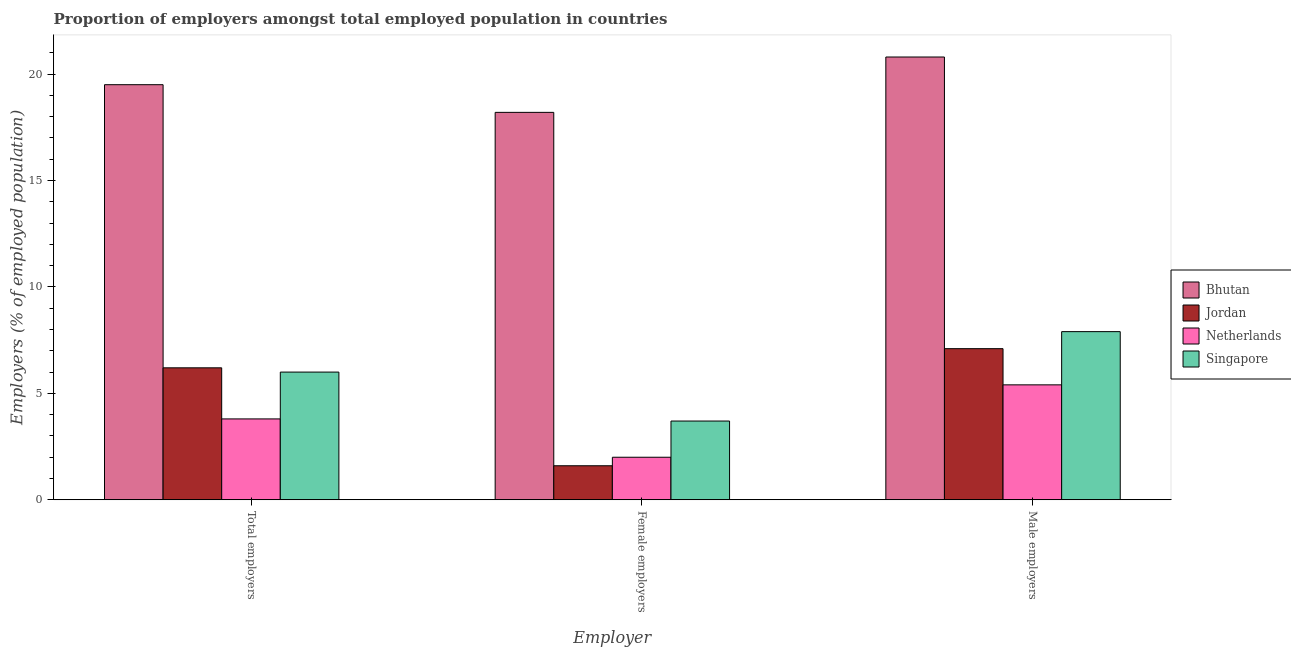How many different coloured bars are there?
Provide a short and direct response. 4. Are the number of bars on each tick of the X-axis equal?
Provide a short and direct response. Yes. How many bars are there on the 3rd tick from the left?
Your response must be concise. 4. What is the label of the 1st group of bars from the left?
Ensure brevity in your answer.  Total employers. What is the percentage of female employers in Netherlands?
Offer a terse response. 2. Across all countries, what is the maximum percentage of total employers?
Give a very brief answer. 19.5. Across all countries, what is the minimum percentage of total employers?
Your answer should be very brief. 3.8. In which country was the percentage of male employers maximum?
Your answer should be very brief. Bhutan. What is the total percentage of total employers in the graph?
Ensure brevity in your answer.  35.5. What is the difference between the percentage of female employers in Netherlands and that in Jordan?
Make the answer very short. 0.4. What is the difference between the percentage of total employers in Jordan and the percentage of male employers in Netherlands?
Offer a very short reply. 0.8. What is the average percentage of female employers per country?
Give a very brief answer. 6.38. What is the difference between the percentage of total employers and percentage of female employers in Bhutan?
Your answer should be compact. 1.3. In how many countries, is the percentage of female employers greater than 1 %?
Offer a very short reply. 4. What is the ratio of the percentage of female employers in Singapore to that in Jordan?
Your response must be concise. 2.31. Is the percentage of male employers in Bhutan less than that in Netherlands?
Provide a short and direct response. No. What is the difference between the highest and the second highest percentage of total employers?
Ensure brevity in your answer.  13.3. What is the difference between the highest and the lowest percentage of female employers?
Offer a very short reply. 16.6. What does the 4th bar from the left in Male employers represents?
Provide a short and direct response. Singapore. What does the 1st bar from the right in Female employers represents?
Offer a very short reply. Singapore. How many bars are there?
Your answer should be compact. 12. Are all the bars in the graph horizontal?
Make the answer very short. No. Does the graph contain any zero values?
Keep it short and to the point. No. How are the legend labels stacked?
Ensure brevity in your answer.  Vertical. What is the title of the graph?
Offer a terse response. Proportion of employers amongst total employed population in countries. Does "Timor-Leste" appear as one of the legend labels in the graph?
Your answer should be very brief. No. What is the label or title of the X-axis?
Your answer should be compact. Employer. What is the label or title of the Y-axis?
Your answer should be very brief. Employers (% of employed population). What is the Employers (% of employed population) of Bhutan in Total employers?
Your response must be concise. 19.5. What is the Employers (% of employed population) in Jordan in Total employers?
Your answer should be very brief. 6.2. What is the Employers (% of employed population) of Netherlands in Total employers?
Offer a terse response. 3.8. What is the Employers (% of employed population) of Singapore in Total employers?
Ensure brevity in your answer.  6. What is the Employers (% of employed population) in Bhutan in Female employers?
Offer a very short reply. 18.2. What is the Employers (% of employed population) of Jordan in Female employers?
Make the answer very short. 1.6. What is the Employers (% of employed population) of Netherlands in Female employers?
Keep it short and to the point. 2. What is the Employers (% of employed population) in Singapore in Female employers?
Offer a very short reply. 3.7. What is the Employers (% of employed population) of Bhutan in Male employers?
Your answer should be compact. 20.8. What is the Employers (% of employed population) of Jordan in Male employers?
Offer a terse response. 7.1. What is the Employers (% of employed population) in Netherlands in Male employers?
Ensure brevity in your answer.  5.4. What is the Employers (% of employed population) of Singapore in Male employers?
Provide a succinct answer. 7.9. Across all Employer, what is the maximum Employers (% of employed population) of Bhutan?
Your answer should be very brief. 20.8. Across all Employer, what is the maximum Employers (% of employed population) in Jordan?
Keep it short and to the point. 7.1. Across all Employer, what is the maximum Employers (% of employed population) in Netherlands?
Keep it short and to the point. 5.4. Across all Employer, what is the maximum Employers (% of employed population) in Singapore?
Give a very brief answer. 7.9. Across all Employer, what is the minimum Employers (% of employed population) of Bhutan?
Offer a very short reply. 18.2. Across all Employer, what is the minimum Employers (% of employed population) in Jordan?
Your answer should be very brief. 1.6. Across all Employer, what is the minimum Employers (% of employed population) of Singapore?
Ensure brevity in your answer.  3.7. What is the total Employers (% of employed population) of Bhutan in the graph?
Your response must be concise. 58.5. What is the total Employers (% of employed population) in Singapore in the graph?
Your response must be concise. 17.6. What is the difference between the Employers (% of employed population) in Bhutan in Total employers and that in Male employers?
Your answer should be compact. -1.3. What is the difference between the Employers (% of employed population) in Netherlands in Total employers and that in Male employers?
Give a very brief answer. -1.6. What is the difference between the Employers (% of employed population) of Bhutan in Female employers and that in Male employers?
Keep it short and to the point. -2.6. What is the difference between the Employers (% of employed population) of Netherlands in Female employers and that in Male employers?
Give a very brief answer. -3.4. What is the difference between the Employers (% of employed population) of Singapore in Female employers and that in Male employers?
Offer a very short reply. -4.2. What is the difference between the Employers (% of employed population) in Bhutan in Total employers and the Employers (% of employed population) in Jordan in Female employers?
Provide a short and direct response. 17.9. What is the difference between the Employers (% of employed population) of Bhutan in Total employers and the Employers (% of employed population) of Singapore in Female employers?
Your response must be concise. 15.8. What is the difference between the Employers (% of employed population) of Jordan in Total employers and the Employers (% of employed population) of Netherlands in Female employers?
Offer a very short reply. 4.2. What is the difference between the Employers (% of employed population) in Bhutan in Total employers and the Employers (% of employed population) in Netherlands in Male employers?
Provide a short and direct response. 14.1. What is the difference between the Employers (% of employed population) of Bhutan in Total employers and the Employers (% of employed population) of Singapore in Male employers?
Give a very brief answer. 11.6. What is the difference between the Employers (% of employed population) in Jordan in Total employers and the Employers (% of employed population) in Netherlands in Male employers?
Make the answer very short. 0.8. What is the difference between the Employers (% of employed population) in Netherlands in Total employers and the Employers (% of employed population) in Singapore in Male employers?
Make the answer very short. -4.1. What is the average Employers (% of employed population) of Bhutan per Employer?
Offer a terse response. 19.5. What is the average Employers (% of employed population) in Jordan per Employer?
Your answer should be compact. 4.97. What is the average Employers (% of employed population) in Netherlands per Employer?
Give a very brief answer. 3.73. What is the average Employers (% of employed population) in Singapore per Employer?
Ensure brevity in your answer.  5.87. What is the difference between the Employers (% of employed population) of Bhutan and Employers (% of employed population) of Singapore in Total employers?
Your answer should be compact. 13.5. What is the difference between the Employers (% of employed population) in Jordan and Employers (% of employed population) in Netherlands in Total employers?
Keep it short and to the point. 2.4. What is the difference between the Employers (% of employed population) of Netherlands and Employers (% of employed population) of Singapore in Total employers?
Your answer should be compact. -2.2. What is the difference between the Employers (% of employed population) of Bhutan and Employers (% of employed population) of Netherlands in Female employers?
Offer a terse response. 16.2. What is the difference between the Employers (% of employed population) of Netherlands and Employers (% of employed population) of Singapore in Female employers?
Ensure brevity in your answer.  -1.7. What is the difference between the Employers (% of employed population) of Bhutan and Employers (% of employed population) of Netherlands in Male employers?
Offer a terse response. 15.4. What is the difference between the Employers (% of employed population) in Bhutan and Employers (% of employed population) in Singapore in Male employers?
Keep it short and to the point. 12.9. What is the difference between the Employers (% of employed population) in Jordan and Employers (% of employed population) in Netherlands in Male employers?
Give a very brief answer. 1.7. What is the ratio of the Employers (% of employed population) in Bhutan in Total employers to that in Female employers?
Your response must be concise. 1.07. What is the ratio of the Employers (% of employed population) of Jordan in Total employers to that in Female employers?
Your answer should be very brief. 3.88. What is the ratio of the Employers (% of employed population) in Netherlands in Total employers to that in Female employers?
Make the answer very short. 1.9. What is the ratio of the Employers (% of employed population) of Singapore in Total employers to that in Female employers?
Your answer should be compact. 1.62. What is the ratio of the Employers (% of employed population) of Jordan in Total employers to that in Male employers?
Provide a succinct answer. 0.87. What is the ratio of the Employers (% of employed population) of Netherlands in Total employers to that in Male employers?
Ensure brevity in your answer.  0.7. What is the ratio of the Employers (% of employed population) in Singapore in Total employers to that in Male employers?
Give a very brief answer. 0.76. What is the ratio of the Employers (% of employed population) in Jordan in Female employers to that in Male employers?
Offer a very short reply. 0.23. What is the ratio of the Employers (% of employed population) of Netherlands in Female employers to that in Male employers?
Make the answer very short. 0.37. What is the ratio of the Employers (% of employed population) in Singapore in Female employers to that in Male employers?
Give a very brief answer. 0.47. What is the difference between the highest and the second highest Employers (% of employed population) of Bhutan?
Provide a short and direct response. 1.3. What is the difference between the highest and the second highest Employers (% of employed population) in Jordan?
Offer a terse response. 0.9. What is the difference between the highest and the lowest Employers (% of employed population) of Bhutan?
Offer a terse response. 2.6. What is the difference between the highest and the lowest Employers (% of employed population) in Jordan?
Make the answer very short. 5.5. What is the difference between the highest and the lowest Employers (% of employed population) of Singapore?
Your answer should be compact. 4.2. 